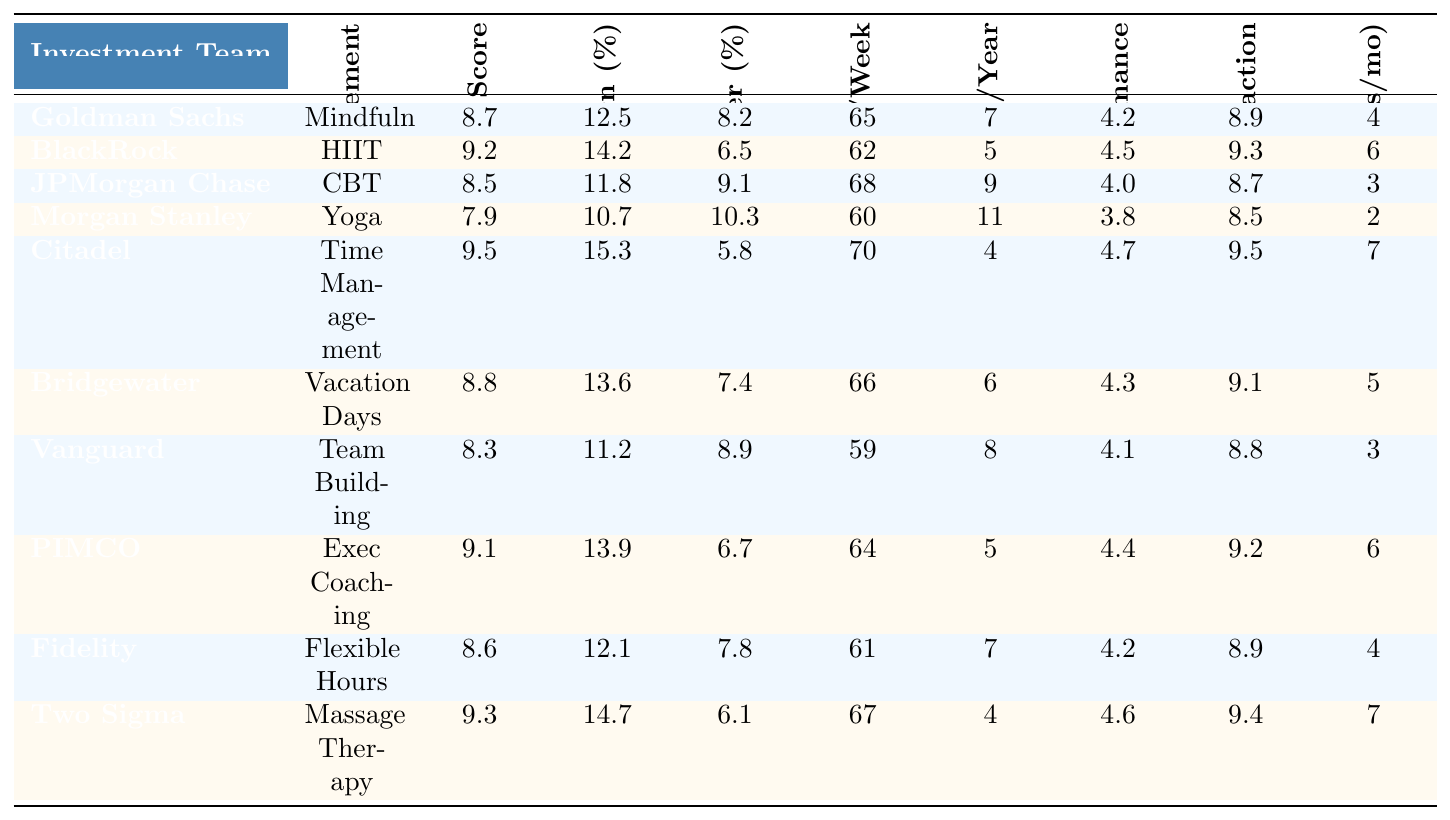What is the productivity level score of Citadel Securities? The table lists Citadel Securities with a productivity level score of 9.5.
Answer: 9.5 Which investment team has the highest risk-adjusted return percentage? Reviewing the risk-adjusted return percentages, Citadel Securities has the highest at 15.3.
Answer: Citadel Securities What is the average employee turnover rate percentage across all investment teams? Summing the employee turnover rates (8.2 + 6.5 + 9.1 + 10.3 + 5.8 + 7.4 + 8.9 + 6.7 + 7.8 + 6.1) gives 69.8. Dividing by 10 teams gives an average of 69.8 / 10 = 6.98.
Answer: 6.98 Is the productivity level score of Goldman Sachs higher than the team performance rating of Morgan Stanley? Goldman Sachs has a productivity score of 8.7, while Morgan Stanley has a team performance rating of 3.8. Therefore, 8.7 > 3.8 is true.
Answer: Yes Which investment team has both a higher productivity level score and a higher risk-adjusted return percentage than Fidelity Investments? Fidelity has a productivity score of 8.6 and a risk-adjusted return of 12.1. Checking other teams, BlackRock (9.2, 14.2) and Two Sigma (9.3, 14.7) exceed both of these values.
Answer: BlackRock and Two Sigma Calculate the difference in the average hours worked per week between the team with the highest and the lowest productivity score. The lowest productivity score is from Morgan Stanley (7.9) and the highest from Citadel (9.5). Citadel works 70 hours per week and Morgan Stanley works 60. The difference is 70 - 60 = 10.
Answer: 10 Is the stress management technique “Time Management Workshops” associated with a lower risk-adjusted return percentage than the technique “Team Building Retreats”? Time Management Workshops have a risk-adjusted return of 15.3, while Team Building Retreats have 11.2. Since 15.3 > 11.2, the statement is false.
Answer: No What is the correlation between stress-related sick days per year and employee turnover rate percentage? Summing the sick days (7, 5, 9, 11, 4, 6, 8, 5, 7, 4) gives 66; the turnover percentages sum to 69.8. To find correlation, we would generally need additional calculations, but noticing that turnover is lower in teams with fewer sick days suggests a negative correlation.
Answer: Negative correlation likely exists Among the teams, who has the lowest client satisfaction score, and what is that score? The lowest client satisfaction score, from Morgan Stanley, is 8.5.
Answer: 8.5 What stress management technique appears to be used by the team with the highest team performance rating? The highest team performance rating is 4.7, and this corresponds to Citadel, which uses Time Management Workshops.
Answer: Time Management Workshops 